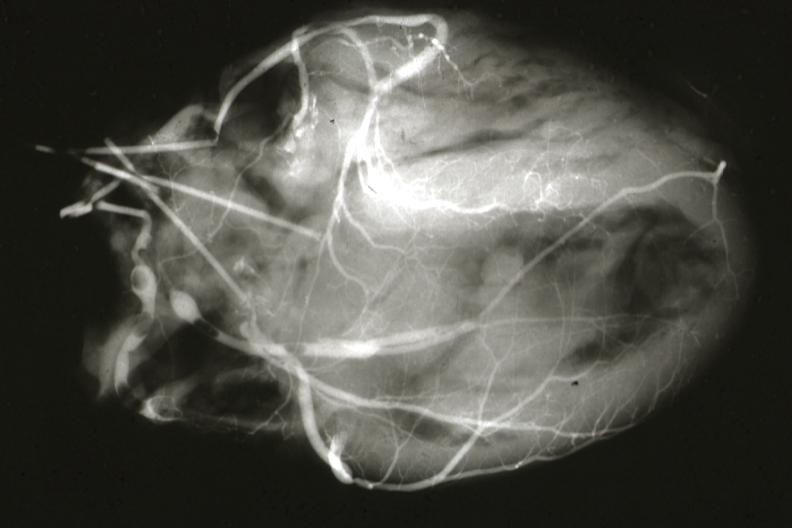s cardiovascular present?
Answer the question using a single word or phrase. Yes 